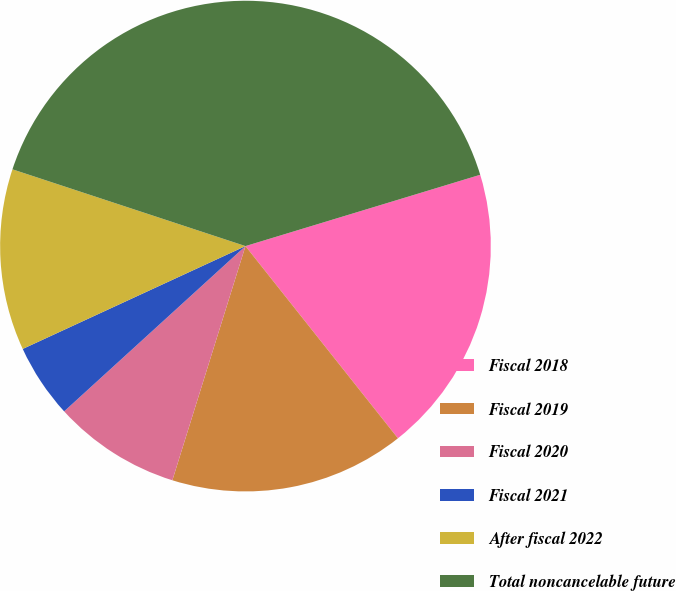Convert chart. <chart><loc_0><loc_0><loc_500><loc_500><pie_chart><fcel>Fiscal 2018<fcel>Fiscal 2019<fcel>Fiscal 2020<fcel>Fiscal 2021<fcel>After fiscal 2022<fcel>Total noncancelable future<nl><fcel>19.02%<fcel>15.49%<fcel>8.42%<fcel>4.88%<fcel>11.95%<fcel>40.24%<nl></chart> 